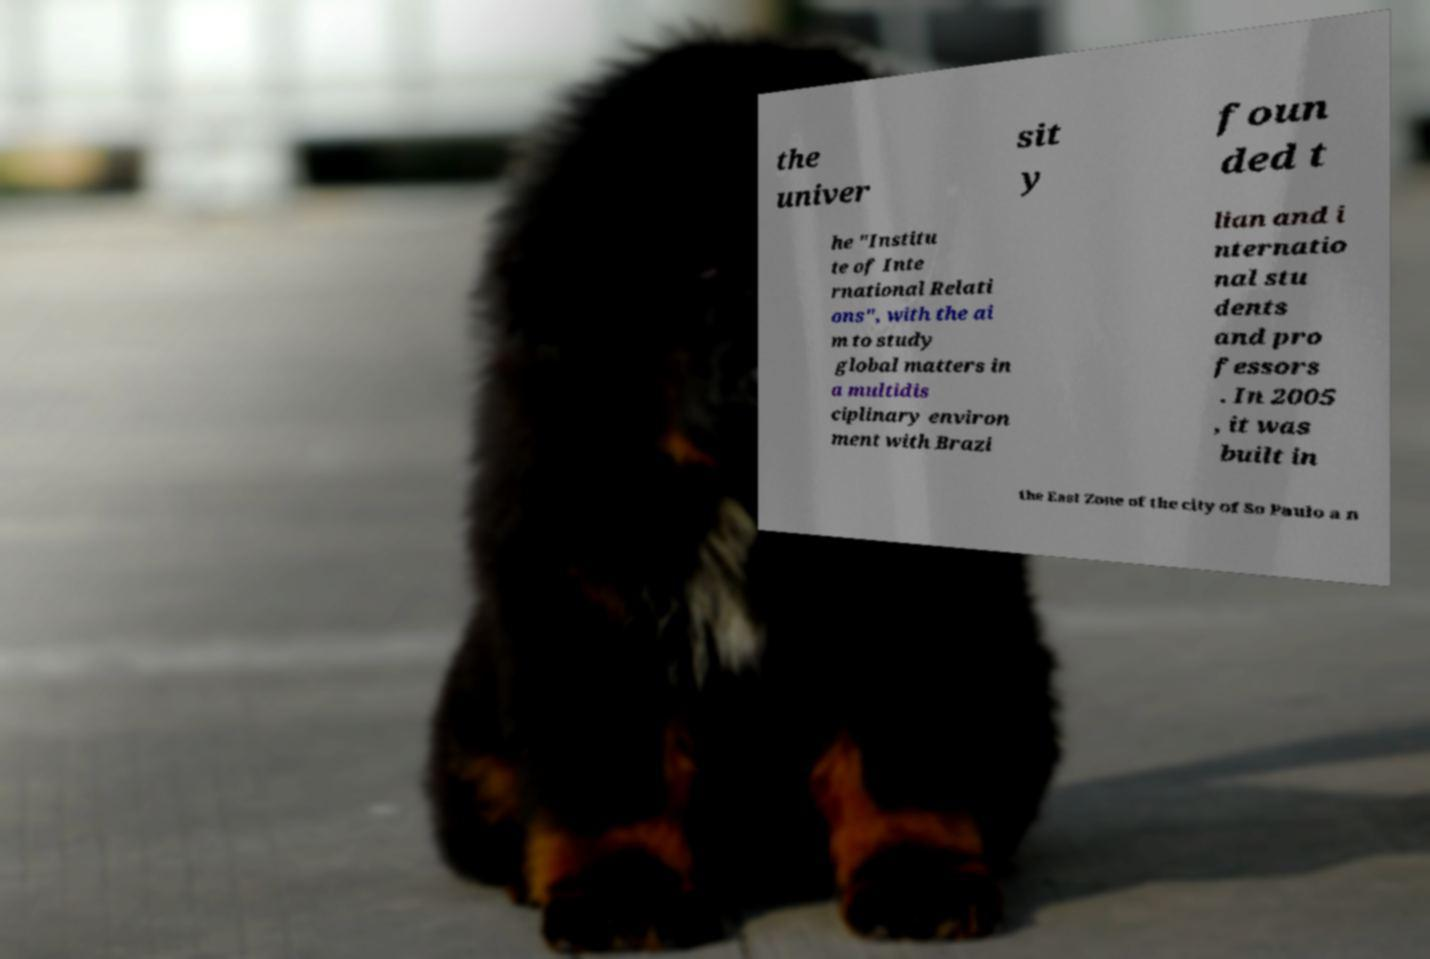Can you accurately transcribe the text from the provided image for me? the univer sit y foun ded t he "Institu te of Inte rnational Relati ons", with the ai m to study global matters in a multidis ciplinary environ ment with Brazi lian and i nternatio nal stu dents and pro fessors . In 2005 , it was built in the East Zone of the city of So Paulo a n 